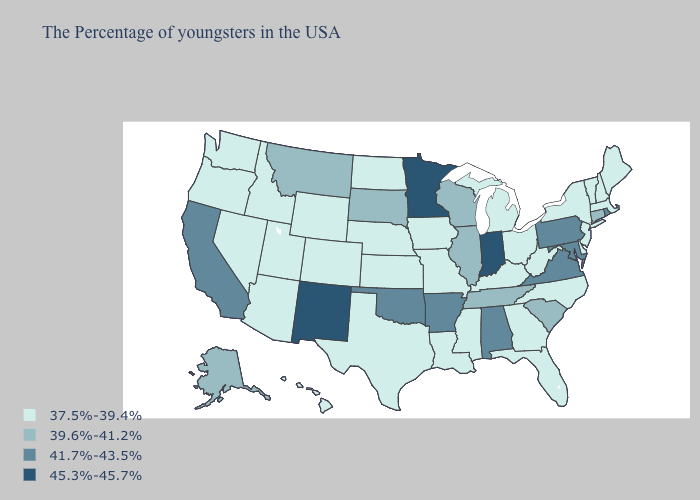Does Tennessee have the lowest value in the South?
Quick response, please. No. Does the map have missing data?
Write a very short answer. No. Does Virginia have the lowest value in the USA?
Write a very short answer. No. Name the states that have a value in the range 37.5%-39.4%?
Keep it brief. Maine, Massachusetts, New Hampshire, Vermont, New York, New Jersey, Delaware, North Carolina, West Virginia, Ohio, Florida, Georgia, Michigan, Kentucky, Mississippi, Louisiana, Missouri, Iowa, Kansas, Nebraska, Texas, North Dakota, Wyoming, Colorado, Utah, Arizona, Idaho, Nevada, Washington, Oregon, Hawaii. What is the highest value in states that border Oregon?
Quick response, please. 41.7%-43.5%. Does Indiana have the highest value in the MidWest?
Concise answer only. Yes. Among the states that border West Virginia , which have the lowest value?
Answer briefly. Ohio, Kentucky. Does Minnesota have the highest value in the USA?
Give a very brief answer. Yes. Does Missouri have the highest value in the MidWest?
Give a very brief answer. No. What is the value of Kentucky?
Quick response, please. 37.5%-39.4%. Does the first symbol in the legend represent the smallest category?
Quick response, please. Yes. Which states have the lowest value in the MidWest?
Quick response, please. Ohio, Michigan, Missouri, Iowa, Kansas, Nebraska, North Dakota. Does Minnesota have the lowest value in the MidWest?
Keep it brief. No. Name the states that have a value in the range 37.5%-39.4%?
Concise answer only. Maine, Massachusetts, New Hampshire, Vermont, New York, New Jersey, Delaware, North Carolina, West Virginia, Ohio, Florida, Georgia, Michigan, Kentucky, Mississippi, Louisiana, Missouri, Iowa, Kansas, Nebraska, Texas, North Dakota, Wyoming, Colorado, Utah, Arizona, Idaho, Nevada, Washington, Oregon, Hawaii. What is the highest value in the USA?
Short answer required. 45.3%-45.7%. 